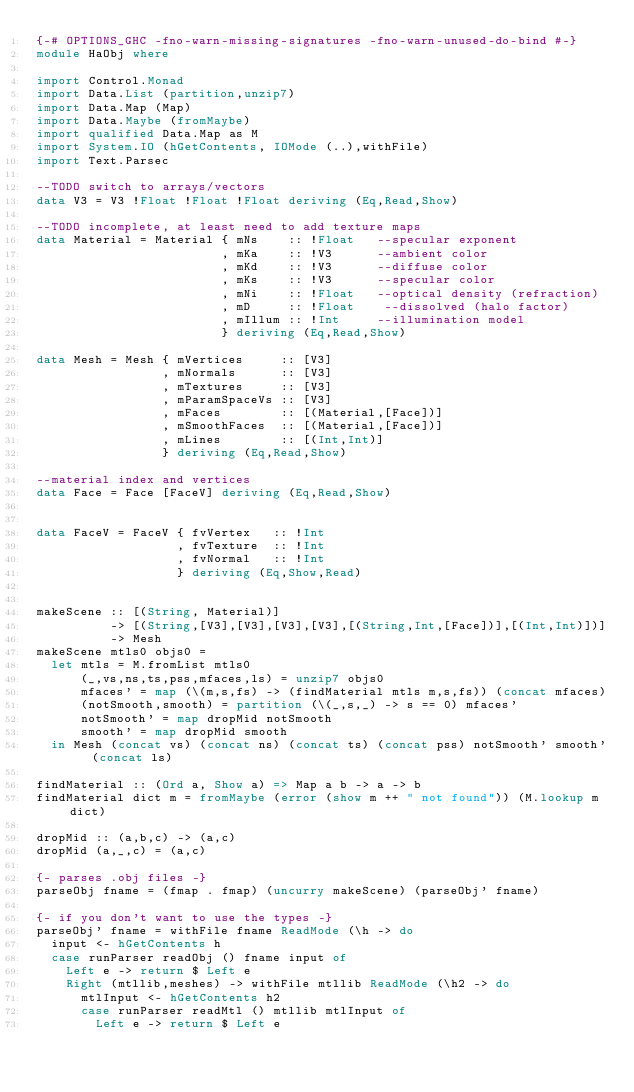<code> <loc_0><loc_0><loc_500><loc_500><_Haskell_>{-# OPTIONS_GHC -fno-warn-missing-signatures -fno-warn-unused-do-bind #-}
module HaObj where

import Control.Monad
import Data.List (partition,unzip7)
import Data.Map (Map)
import Data.Maybe (fromMaybe)
import qualified Data.Map as M
import System.IO (hGetContents, IOMode (..),withFile)
import Text.Parsec

--TODO switch to arrays/vectors
data V3 = V3 !Float !Float !Float deriving (Eq,Read,Show)

--TODO incomplete, at least need to add texture maps
data Material = Material { mNs    :: !Float   --specular exponent
                         , mKa    :: !V3      --ambient color
                         , mKd    :: !V3      --diffuse color
                         , mKs    :: !V3      --specular color
                         , mNi    :: !Float   --optical density (refraction)
                         , mD     :: !Float    --dissolved (halo factor)
                         , mIllum :: !Int     --illumination model
                         } deriving (Eq,Read,Show)

data Mesh = Mesh { mVertices     :: [V3]
                 , mNormals      :: [V3]
                 , mTextures     :: [V3]
                 , mParamSpaceVs :: [V3]
                 , mFaces        :: [(Material,[Face])]
                 , mSmoothFaces  :: [(Material,[Face])]
                 , mLines        :: [(Int,Int)]
                 } deriving (Eq,Read,Show)

--material index and vertices
data Face = Face [FaceV] deriving (Eq,Read,Show)


data FaceV = FaceV { fvVertex   :: !Int
                   , fvTexture  :: !Int
                   , fvNormal   :: !Int 
                   } deriving (Eq,Show,Read)


makeScene :: [(String, Material)]
          -> [(String,[V3],[V3],[V3],[V3],[(String,Int,[Face])],[(Int,Int)])]
          -> Mesh
makeScene mtls0 objs0 =
  let mtls = M.fromList mtls0
      (_,vs,ns,ts,pss,mfaces,ls) = unzip7 objs0
      mfaces' = map (\(m,s,fs) -> (findMaterial mtls m,s,fs)) (concat mfaces)
      (notSmooth,smooth) = partition (\(_,s,_) -> s == 0) mfaces'
      notSmooth' = map dropMid notSmooth
      smooth' = map dropMid smooth
  in Mesh (concat vs) (concat ns) (concat ts) (concat pss) notSmooth' smooth' (concat ls)

findMaterial :: (Ord a, Show a) => Map a b -> a -> b
findMaterial dict m = fromMaybe (error (show m ++ " not found")) (M.lookup m dict)

dropMid :: (a,b,c) -> (a,c)
dropMid (a,_,c) = (a,c)

{- parses .obj files -}
parseObj fname = (fmap . fmap) (uncurry makeScene) (parseObj' fname)

{- if you don't want to use the types -}
parseObj' fname = withFile fname ReadMode (\h -> do
  input <- hGetContents h
  case runParser readObj () fname input of
    Left e -> return $ Left e
    Right (mtllib,meshes) -> withFile mtllib ReadMode (\h2 -> do
      mtlInput <- hGetContents h2
      case runParser readMtl () mtllib mtlInput of
        Left e -> return $ Left e</code> 